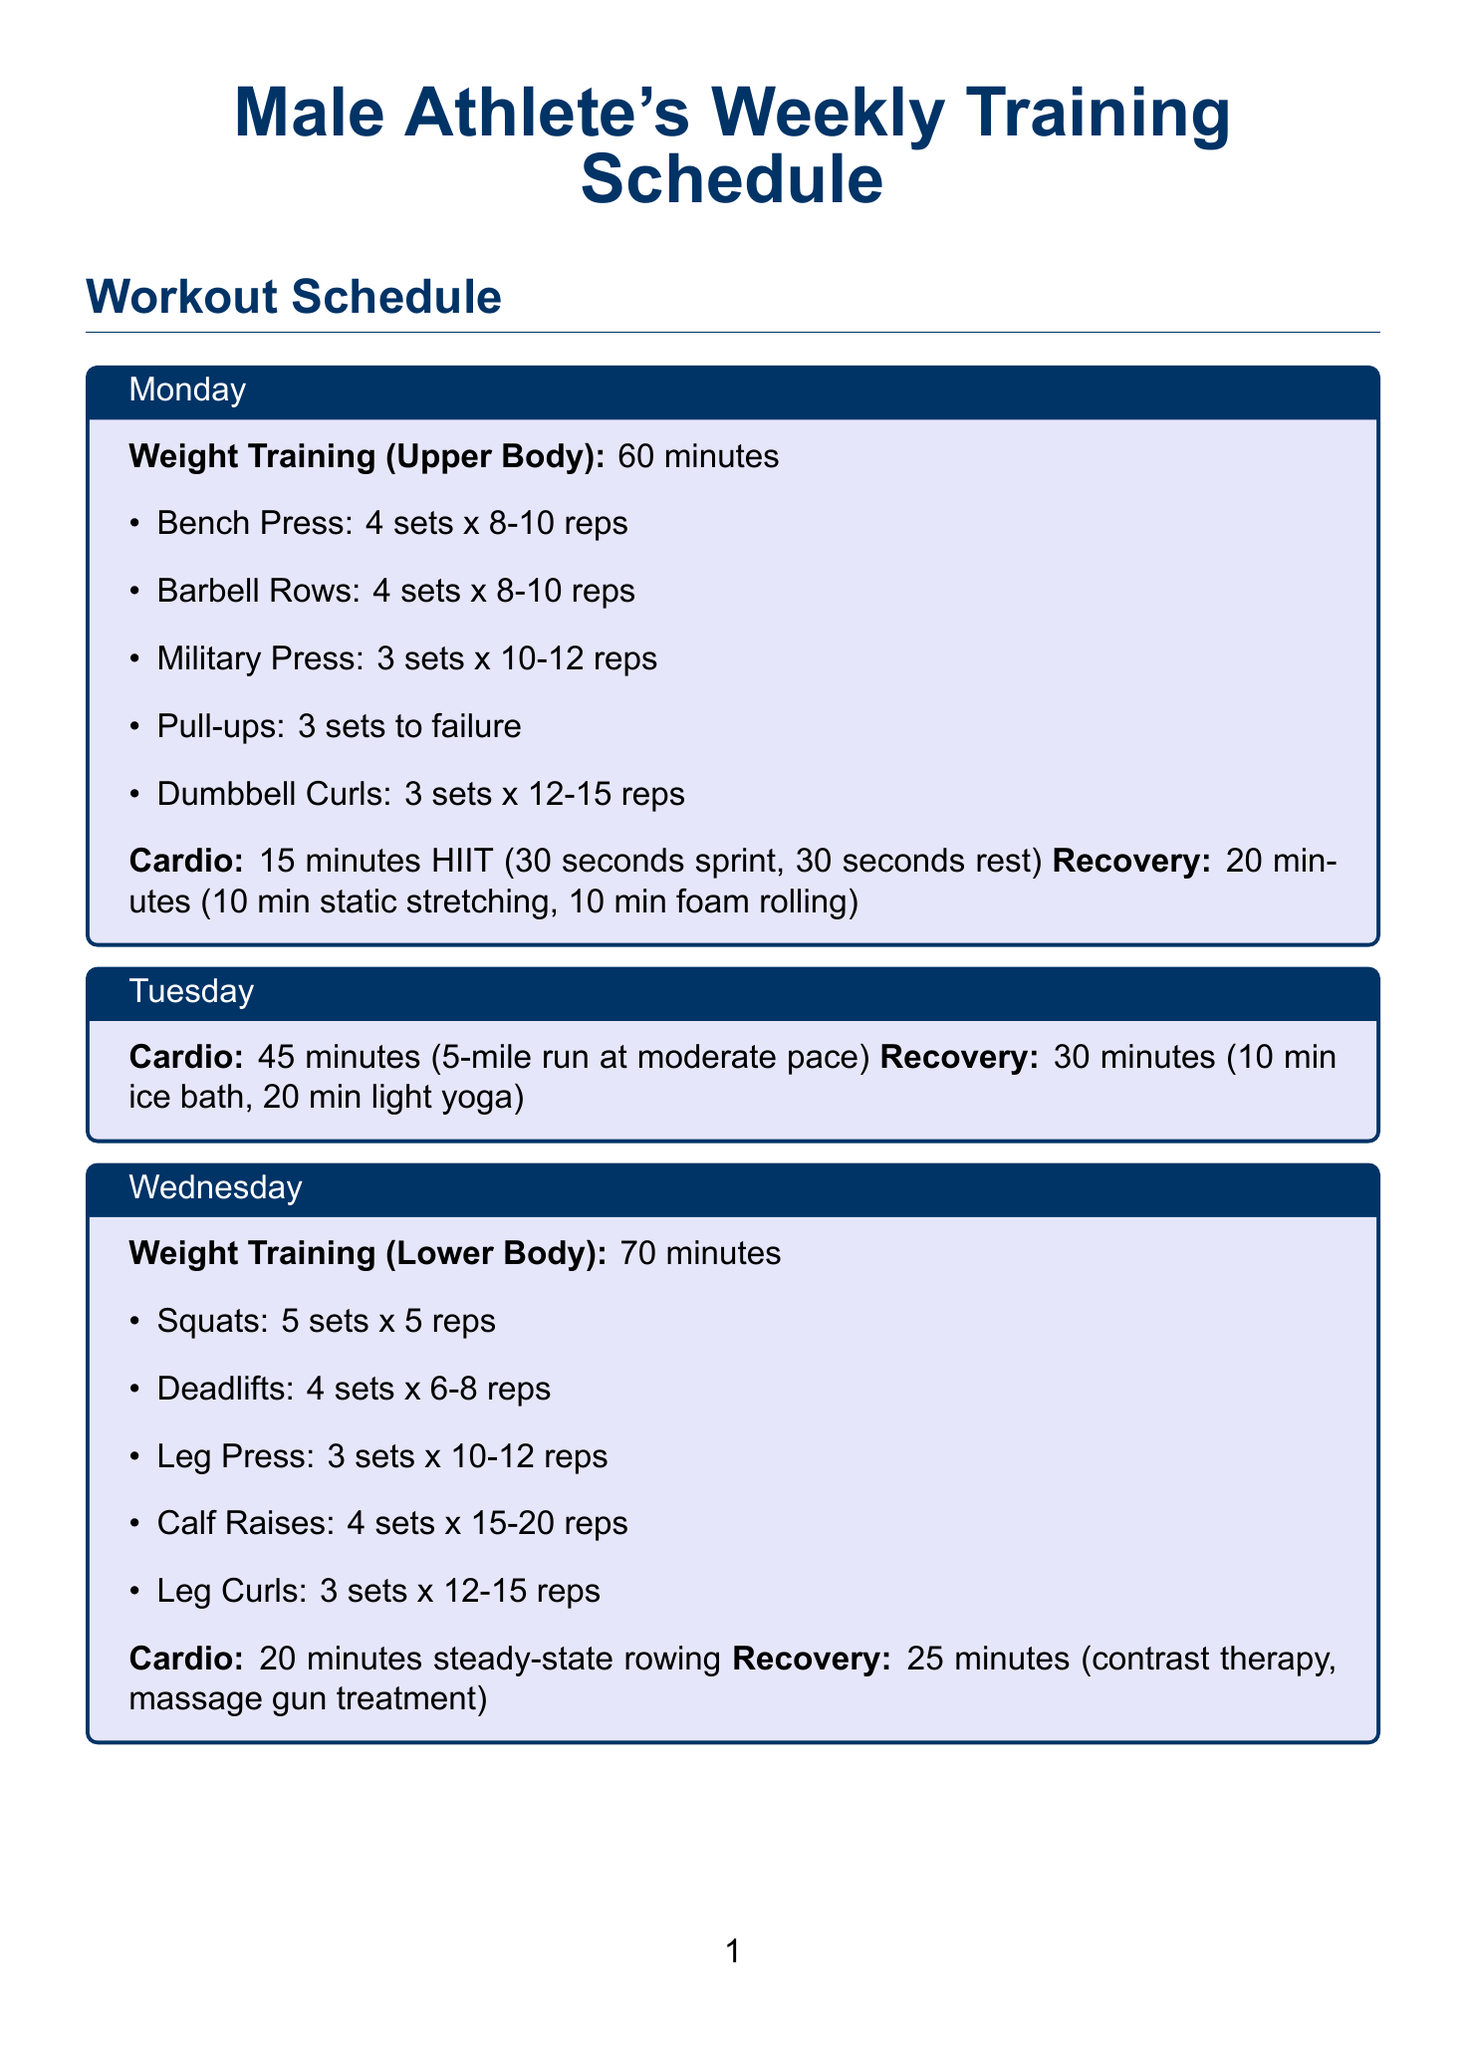What is the duration of the HIIT cardio session on Monday? The duration for the HIIT cardio session on Monday is stated in the activities list.
Answer: 15 minutes How many sets are prescribed for the Bench Press on Monday? The number of sets for the Bench Press is mentioned under the upper body weight training section.
Answer: 4 sets What type of cardio is scheduled for Tuesday? The type of cardio for Tuesday is specified in the activities for that day.
Answer: Distance Running How long is the outdoor training session on Saturday? The duration for the outdoor training session on Saturday is provided in the document.
Answer: 90 minutes What recovery activities are included on Friday? The recovery activities on Friday can be found in the recovery section, which lists different activities.
Answer: Sauna session and static stretching Describe one nutrition tip mentioned in the document. The nutrition tips are listed in the additional tips section.
Answer: High-protein meals What is the primary focus of the weight training on Wednesday? The focus of the weight training on Wednesday is clearly indicated in the activities for that day.
Answer: Lower Body How often should strength tests be conducted according to the performance tracking section? The frequency for conducting strength tests is provided in the performance tracking list.
Answer: Every 8-12 weeks 